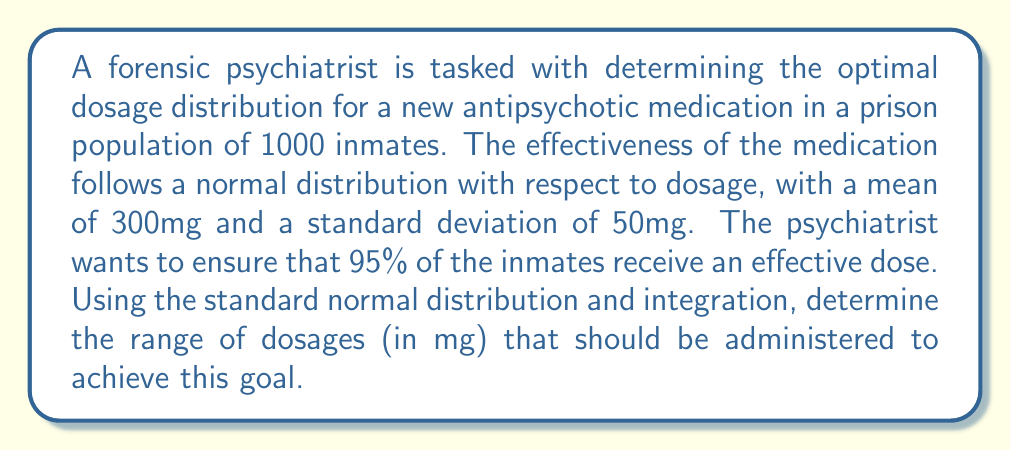Solve this math problem. To solve this problem, we need to use the properties of the normal distribution and integration. Let's approach this step-by-step:

1) First, recall that for a normal distribution, approximately 95% of the data falls within 2 standard deviations of the mean.

2) We're given that the mean (μ) is 300mg and the standard deviation (σ) is 50mg.

3) To find the range that covers 95% of the distribution, we need to calculate μ ± 2σ.

4) Lower bound: $300 - (2 * 50) = 200$ mg
   Upper bound: $300 + (2 * 50) = 400$ mg

5) To verify this using integration, we need to use the standard normal distribution (z-score) and the error function (erf).

6) The z-scores for our bounds are:
   Lower: $z_1 = \frac{200 - 300}{50} = -2$
   Upper: $z_2 = \frac{400 - 300}{50} = 2$

7) The area under the standard normal curve between these z-scores is given by:

   $$P(-2 < Z < 2) = \Phi(2) - \Phi(-2)$$

   where $\Phi(z)$ is the cumulative distribution function of the standard normal distribution.

8) This can be calculated using the error function:

   $$P(-2 < Z < 2) = \frac{1}{2}[1 + \text{erf}(\frac{2}{\sqrt{2}})] - \frac{1}{2}[1 + \text{erf}(\frac{-2}{\sqrt{2}})]$$

9) Simplifying:

   $$P(-2 < Z < 2) = \frac{1}{2}[\text{erf}(\frac{2}{\sqrt{2}}) - \text{erf}(\frac{-2}{\sqrt{2}})] = \text{erf}(\frac{2}{\sqrt{2}}) \approx 0.9545$$

10) This confirms that approximately 95.45% of the distribution falls within this range.
Answer: The optimal dosage range for 95% of the inmate population is 200mg to 400mg. 